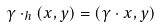<formula> <loc_0><loc_0><loc_500><loc_500>\gamma \cdot _ { h } \left ( x , y \right ) = \left ( \gamma \cdot x , y \right )</formula> 